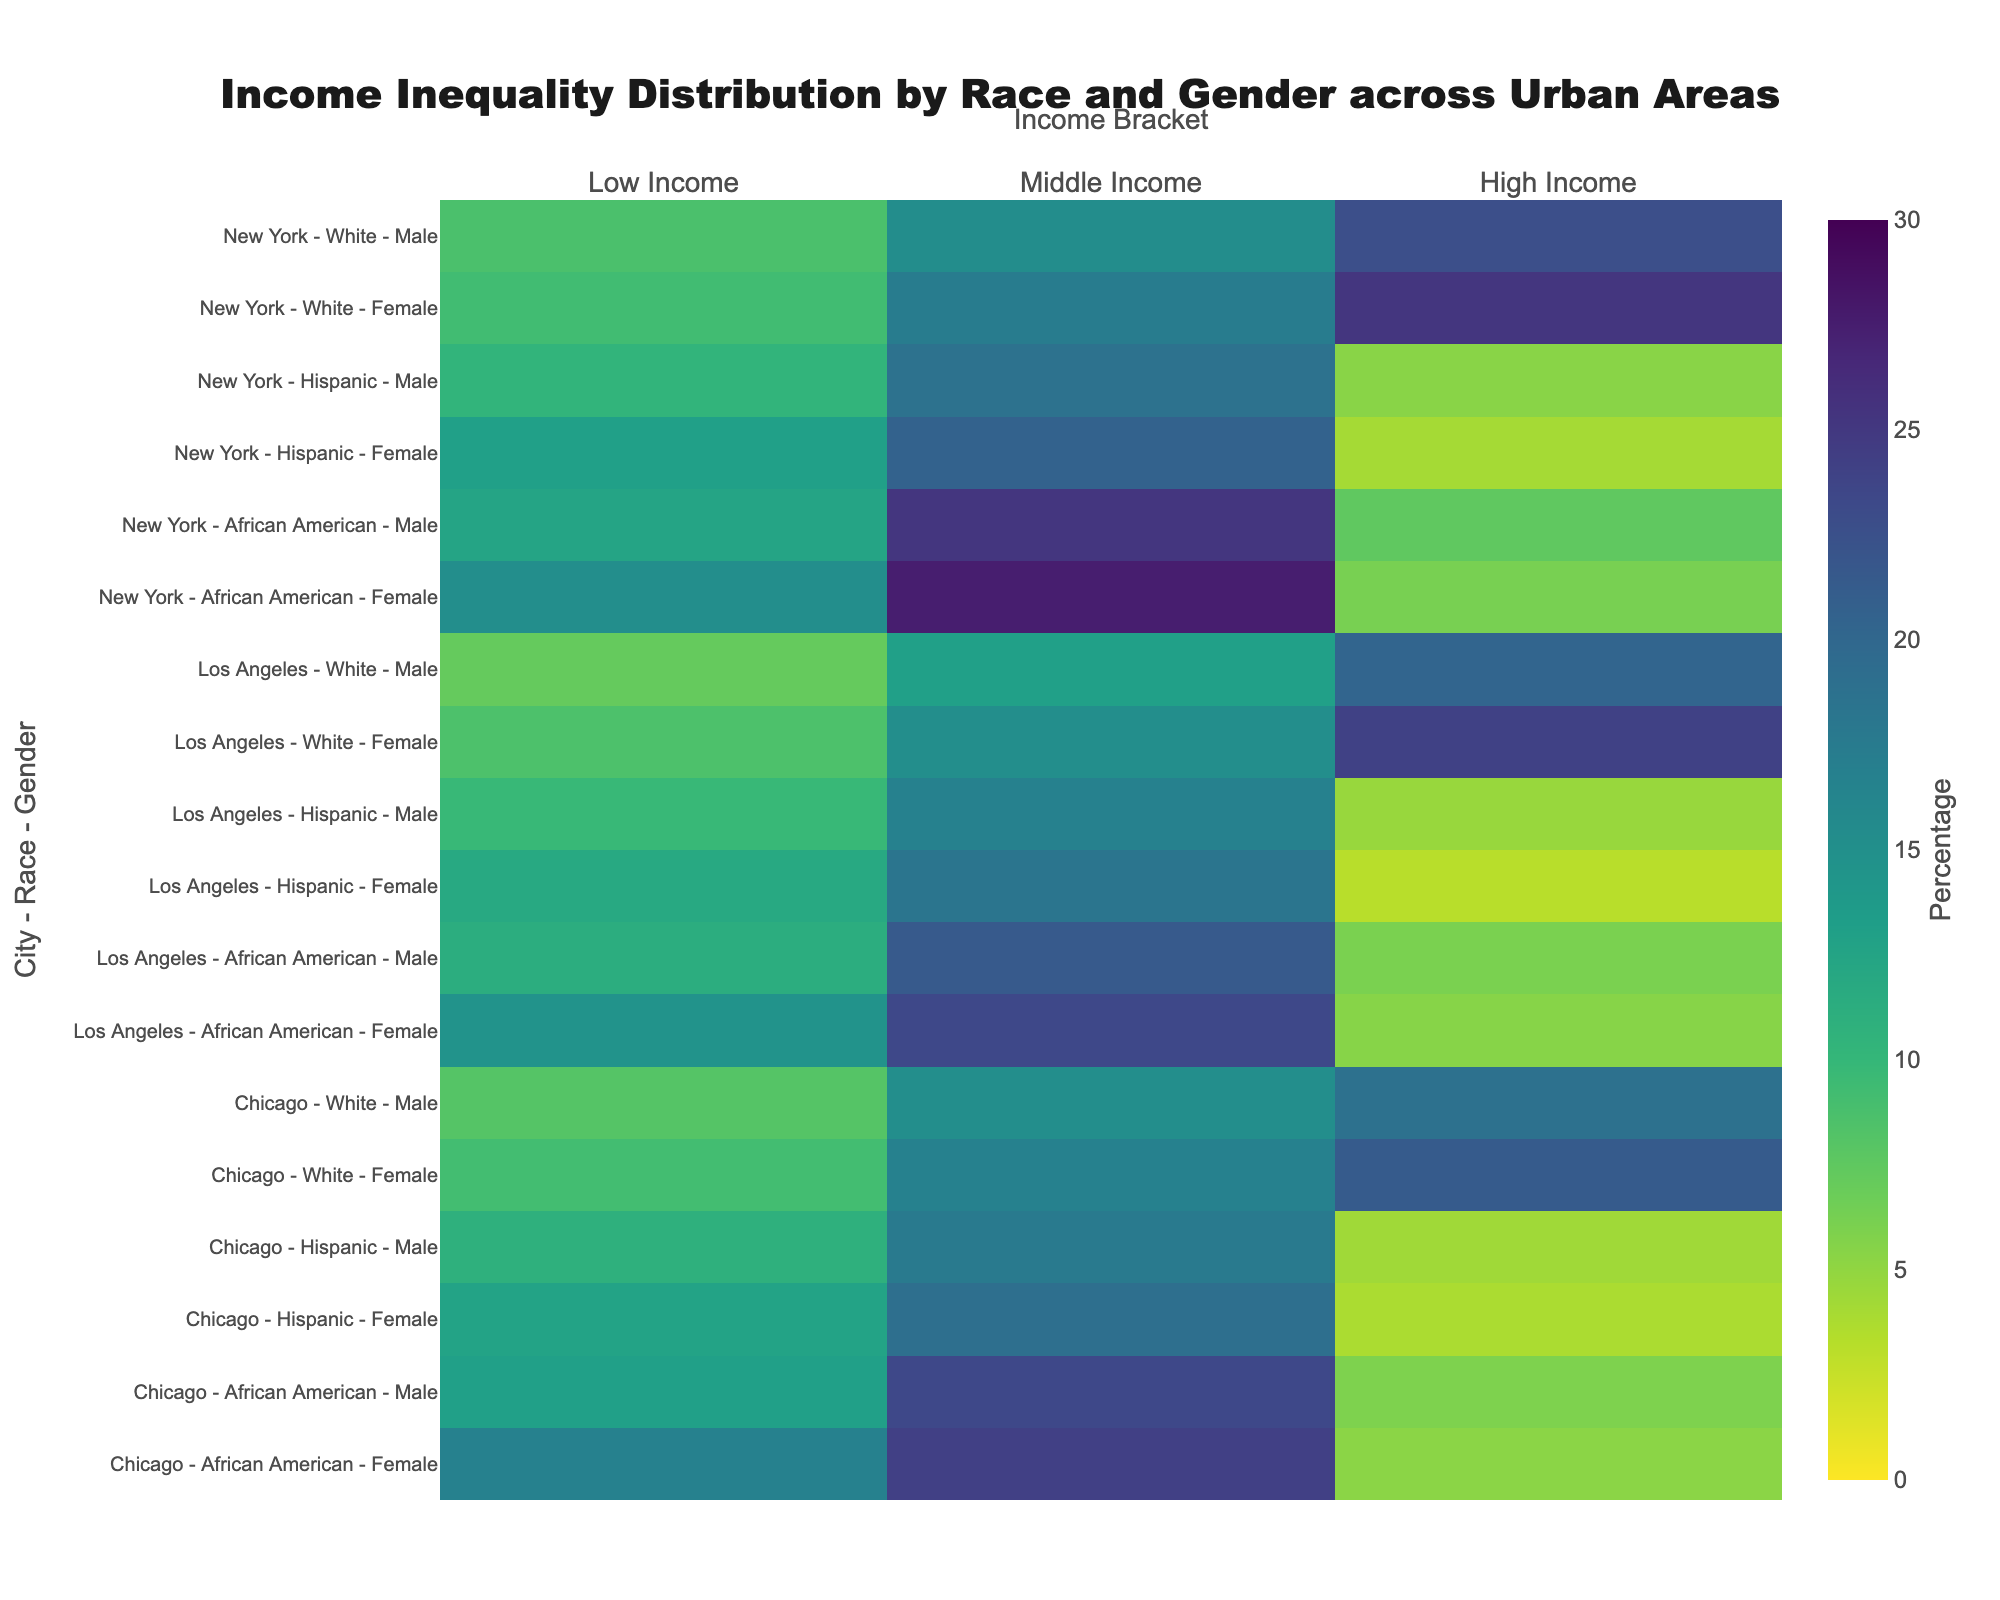What is the title of the figure? The title of a figure is typically located at the top center and is the large, bold text summarizing the content of the visual. The title here is: "Income Inequality Distribution by Race and Gender across Urban Areas."
Answer: Income Inequality Distribution by Race and Gender across Urban Areas Which race and gender group in New York has the highest percentage in the low-income bracket? To find this, locate the rows in New York and check which race and gender combination has the largest value in the "Low Income" column. African American females have the highest percentage at 15.2%.
Answer: African American females How does the percentage of white females in the high-income bracket in New York compare to that in Chicago? Compare the percentage value of white females in New York and Chicago in the "High Income" bracket. New York has 25.3% while Chicago has 21.4%.
Answer: New York is higher What is the combined percentage of middle-income African American females across all cities? Sum the percentage of middle-income African American females in New York (27.5%), Los Angeles (23.4%), and Chicago (24.2%). This totals to 27.5 + 23.4 + 24.2 = 75.1%.
Answer: 75.1% Which city, race, and gender group have the lowest percentage in the high-income bracket? Scan through the "High Income" percentages for each city, race, and gender group to find the smallest number. Hispanic females in Los Angeles have the lowest percentage at 3.2%.
Answer: Hispanic females in Los Angeles Are the high-income percentages for both African American males and females in Los Angeles above 5%? Check if the high-income percentage for African American males (6.1%) and African American females (5.5%) in Los Angeles are both above 5%. Yes, both are above 5%.
Answer: Yes How many different gender categories are present in the figure? Review the y-axis labels or the data table and count the unique categories under gender, which are "Male" and "Female." That's a total of 2 gender categories.
Answer: 2 What is the difference in the percentage of low-income Hispanic males between New York and Los Angeles? Subtract the percentage of low-income Hispanic males in Los Angeles (9.8%) from New York (10.4%). The difference is 10.4 - 9.8 = 0.6%.
Answer: 0.6% Which city has the highest percentage of high-income white males, and what is it? Compare the high-income percentage of white males across all cities listed in the figure. New York has the highest percentage at 22.7%.
Answer: New York at 22.7% 